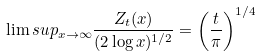Convert formula to latex. <formula><loc_0><loc_0><loc_500><loc_500>\lim s u p _ { x \to \infty } \frac { Z _ { t } ( x ) } { ( 2 \log x ) ^ { 1 / 2 } } = \left ( \frac { t } { \pi } \right ) ^ { 1 / 4 } \quad</formula> 